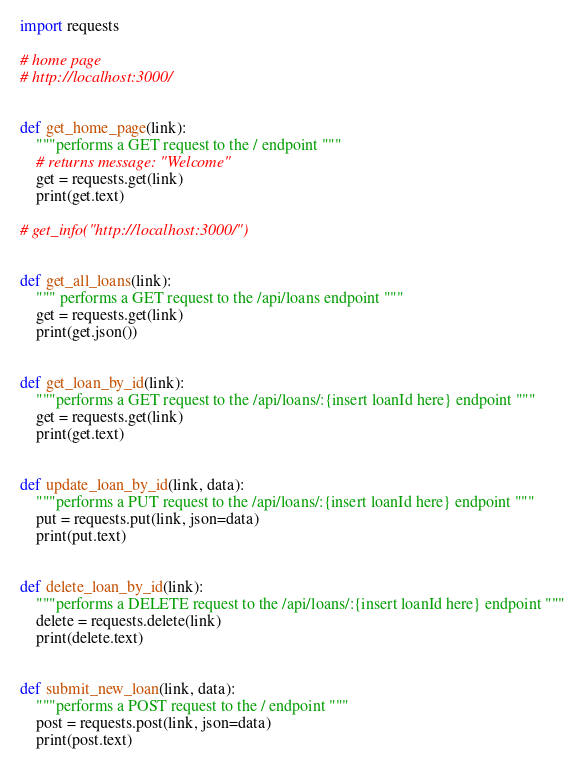Convert code to text. <code><loc_0><loc_0><loc_500><loc_500><_Python_>import requests

# home page
# http://localhost:3000/


def get_home_page(link):
    """performs a GET request to the / endpoint """
    # returns message: "Welcome"
    get = requests.get(link)
    print(get.text)

# get_info("http://localhost:3000/")


def get_all_loans(link):
    """ performs a GET request to the /api/loans endpoint """
    get = requests.get(link)
    print(get.json())


def get_loan_by_id(link):
    """performs a GET request to the /api/loans/:{insert loanId here} endpoint """
    get = requests.get(link)
    print(get.text)


def update_loan_by_id(link, data):
    """performs a PUT request to the /api/loans/:{insert loanId here} endpoint """
    put = requests.put(link, json=data)
    print(put.text)


def delete_loan_by_id(link):
    """performs a DELETE request to the /api/loans/:{insert loanId here} endpoint """
    delete = requests.delete(link)
    print(delete.text)


def submit_new_loan(link, data):
    """performs a POST request to the / endpoint """
    post = requests.post(link, json=data)
    print(post.text)

</code> 